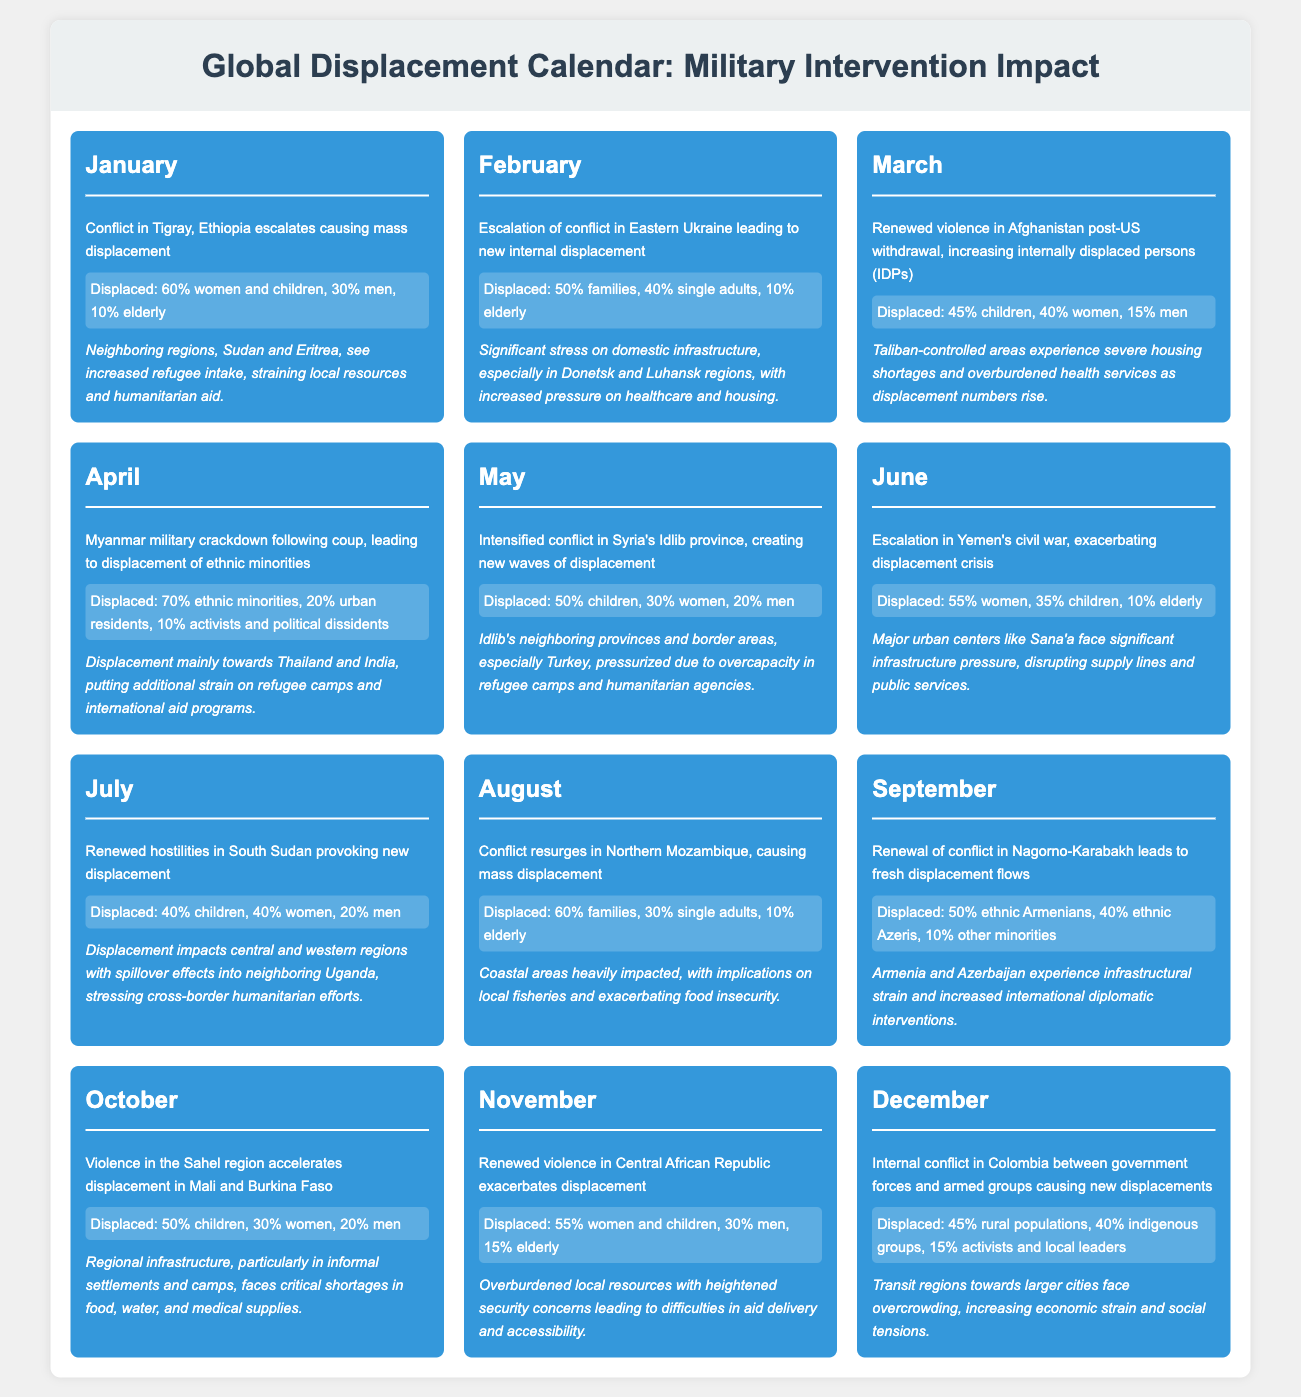What event in January caused mass displacement? The document states that the conflict in Tigray, Ethiopia escalated, leading to mass displacement.
Answer: Conflict in Tigray, Ethiopia What percentage of displaced individuals in Myanmar are ethnic minorities? According to the document, 70% of the displaced in Myanmar are ethnic minorities.
Answer: 70% In which month did the conflict in Eastern Ukraine lead to new internal displacement? The document notes that the escalation of conflict in Eastern Ukraine occurred in February, resulting in new internal displacement.
Answer: February Which demographic group is most affected by displacement in Yemen as of June? The document indicates that 55% of the displaced in Yemen are women.
Answer: 55% women How many months experienced violence that led to displacement in Central African Republic during the year? The document shows that renewed violence in Central African Republic was reported in November, marking it as the only month for that specific conflict leading to displacement.
Answer: 1 month What is the main demographic impacted by the conflict in Syria's Idlib province? The document states that 50% of the displaced in Syria's Idlib province are children.
Answer: 50% children How did the displacement in Northern Mozambique affect the local economy? The document mentions that the coastal areas are heavily impacted, with implications on local fisheries and exacerbating food insecurity.
Answer: Local fisheries and food insecurity What month saw violence in the Sahel region, specifically in Mali and Burkina Faso? The document mentions that violence in the Sahel region accelerated displacement in October.
Answer: October What was the demographic breakdown of the displaced in Afghanistan in March? The document indicates that 45% were children, 40% were women, and 15% were men.
Answer: 45% children, 40% women, 15% men 